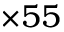Convert formula to latex. <formula><loc_0><loc_0><loc_500><loc_500>\times 5 5</formula> 